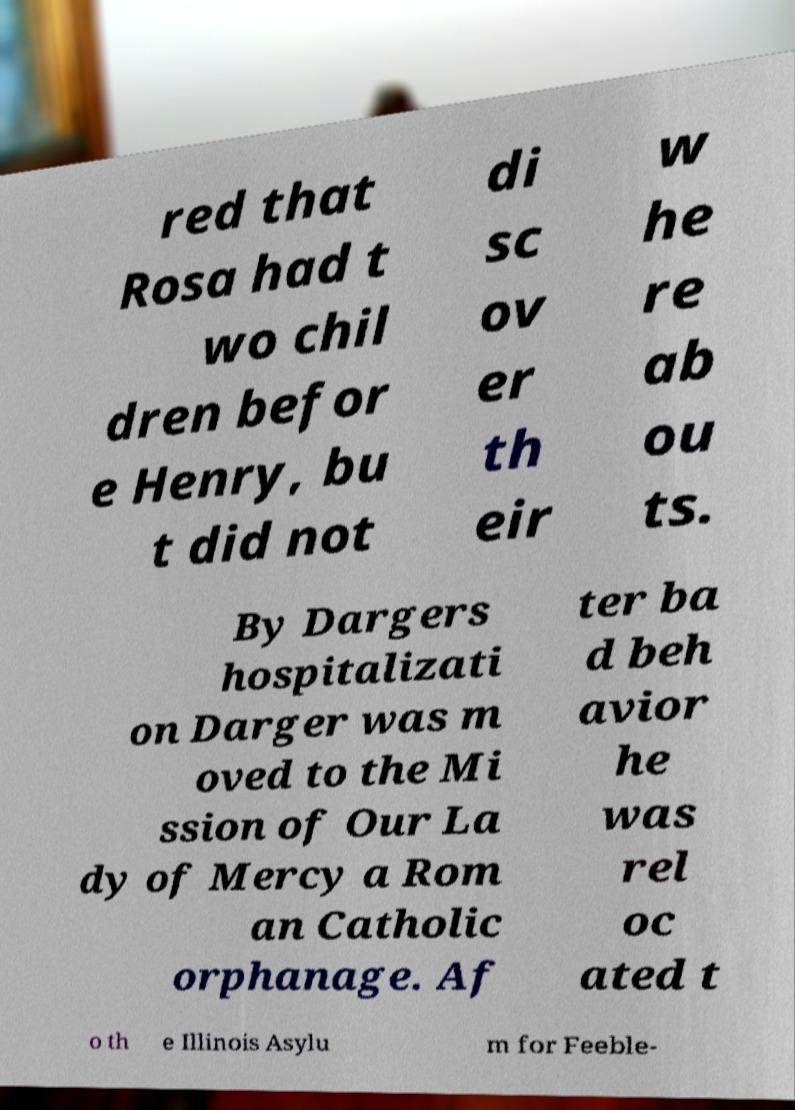Could you extract and type out the text from this image? red that Rosa had t wo chil dren befor e Henry, bu t did not di sc ov er th eir w he re ab ou ts. By Dargers hospitalizati on Darger was m oved to the Mi ssion of Our La dy of Mercy a Rom an Catholic orphanage. Af ter ba d beh avior he was rel oc ated t o th e Illinois Asylu m for Feeble- 